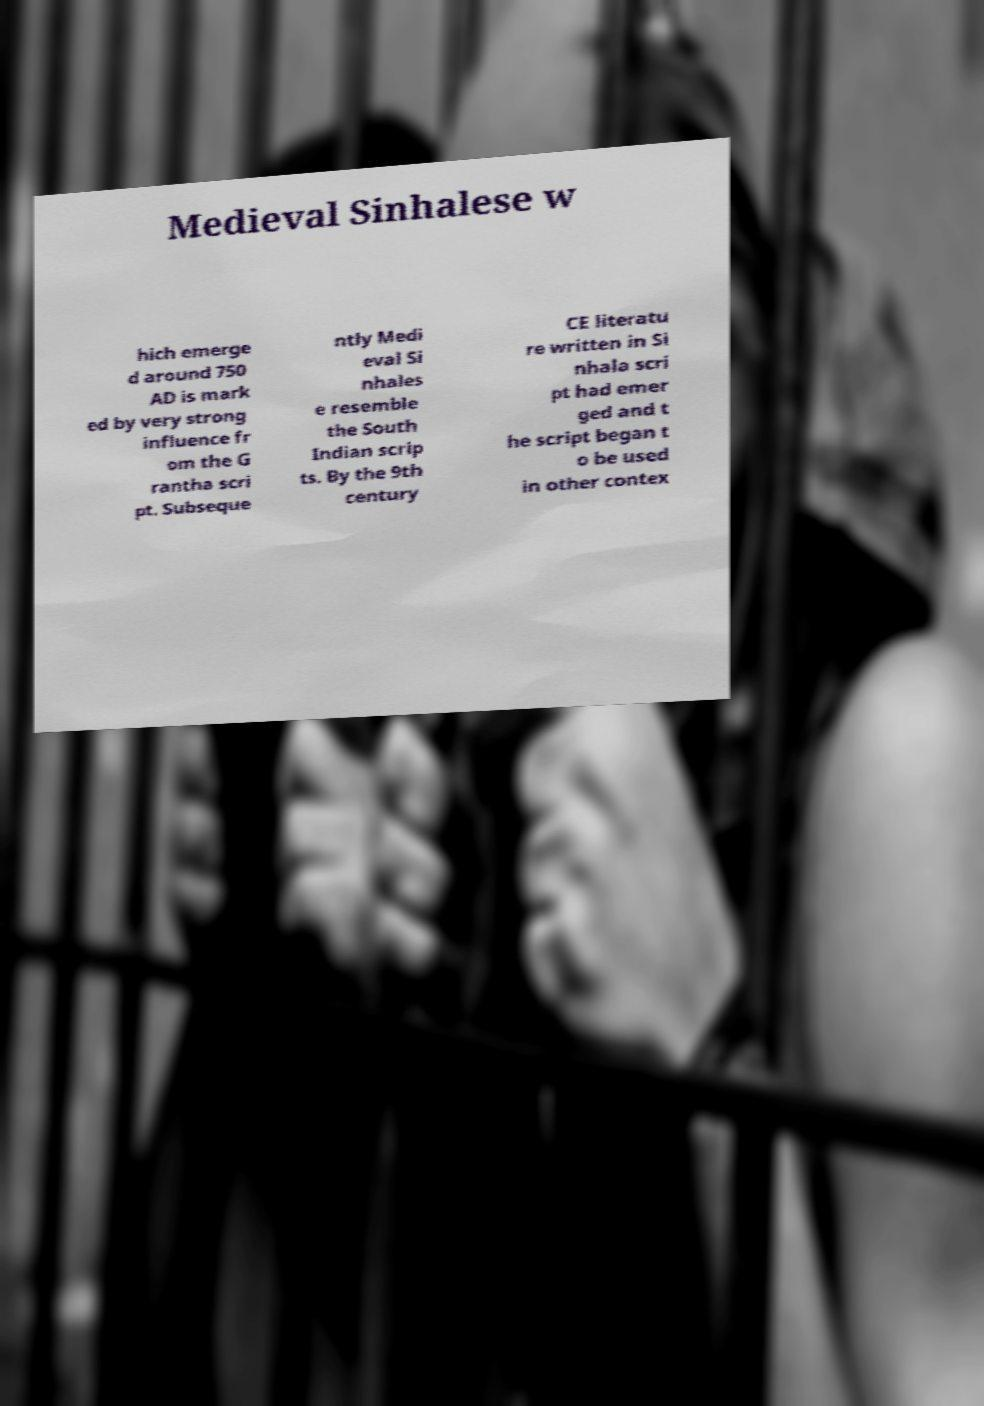I need the written content from this picture converted into text. Can you do that? Medieval Sinhalese w hich emerge d around 750 AD is mark ed by very strong influence fr om the G rantha scri pt. Subseque ntly Medi eval Si nhales e resemble the South Indian scrip ts. By the 9th century CE literatu re written in Si nhala scri pt had emer ged and t he script began t o be used in other contex 